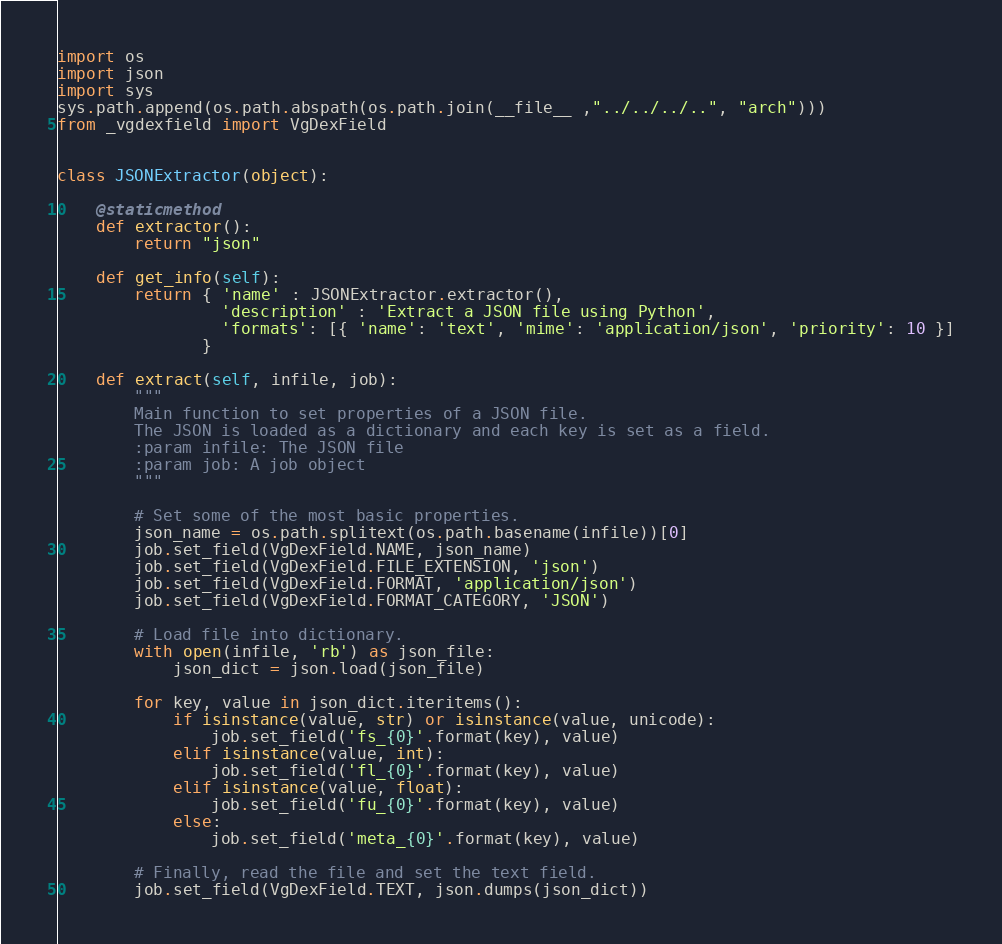<code> <loc_0><loc_0><loc_500><loc_500><_Python_>import os
import json
import sys
sys.path.append(os.path.abspath(os.path.join(__file__ ,"../../../..", "arch")))
from _vgdexfield import VgDexField


class JSONExtractor(object):

    @staticmethod
    def extractor():
        return "json"

    def get_info(self):
        return { 'name' : JSONExtractor.extractor(),
                 'description' : 'Extract a JSON file using Python',
                 'formats': [{ 'name': 'text', 'mime': 'application/json', 'priority': 10 }]
               }

    def extract(self, infile, job):
        """
        Main function to set properties of a JSON file.
        The JSON is loaded as a dictionary and each key is set as a field.
        :param infile: The JSON file
        :param job: A job object
        """

        # Set some of the most basic properties.
        json_name = os.path.splitext(os.path.basename(infile))[0]
        job.set_field(VgDexField.NAME, json_name)
        job.set_field(VgDexField.FILE_EXTENSION, 'json')
        job.set_field(VgDexField.FORMAT, 'application/json')
        job.set_field(VgDexField.FORMAT_CATEGORY, 'JSON')

        # Load file into dictionary.
        with open(infile, 'rb') as json_file:
            json_dict = json.load(json_file)

        for key, value in json_dict.iteritems():
            if isinstance(value, str) or isinstance(value, unicode):
                job.set_field('fs_{0}'.format(key), value)
            elif isinstance(value, int):
                job.set_field('fl_{0}'.format(key), value)
            elif isinstance(value, float):
                job.set_field('fu_{0}'.format(key), value)
            else:
                job.set_field('meta_{0}'.format(key), value)

        # Finally, read the file and set the text field.
        job.set_field(VgDexField.TEXT, json.dumps(json_dict))
</code> 